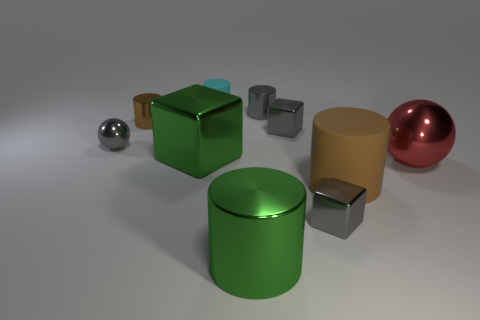Subtract all metal cylinders. How many cylinders are left? 2 Subtract 2 cubes. How many cubes are left? 1 Subtract all blue cylinders. Subtract all yellow spheres. How many cylinders are left? 5 Subtract all gray cylinders. How many red spheres are left? 1 Subtract all metal cylinders. Subtract all big brown cylinders. How many objects are left? 6 Add 3 cyan cylinders. How many cyan cylinders are left? 4 Add 9 tiny purple metal objects. How many tiny purple metal objects exist? 9 Subtract all green cubes. How many cubes are left? 2 Subtract 0 yellow cubes. How many objects are left? 10 Subtract all spheres. How many objects are left? 8 